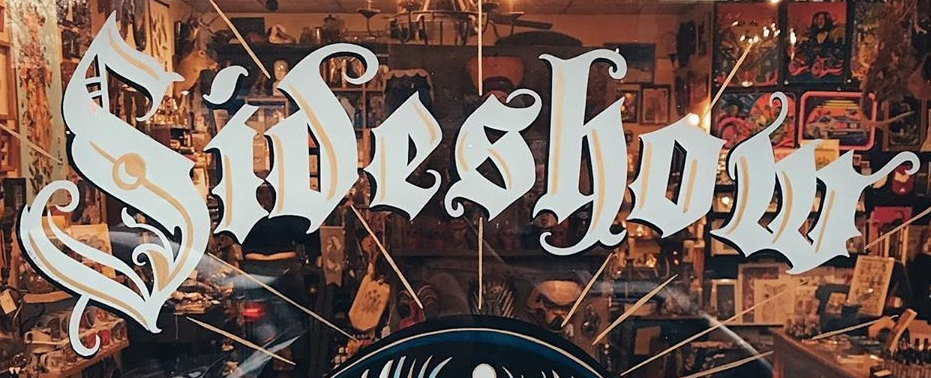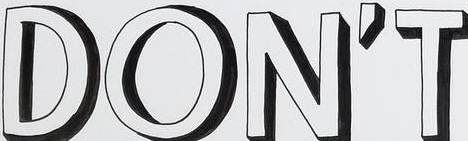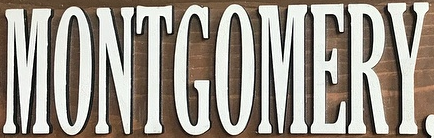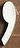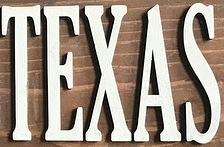What text is displayed in these images sequentially, separated by a semicolon? Sideshow; DON'T; MONTGOMERY; ,; TEXAS 